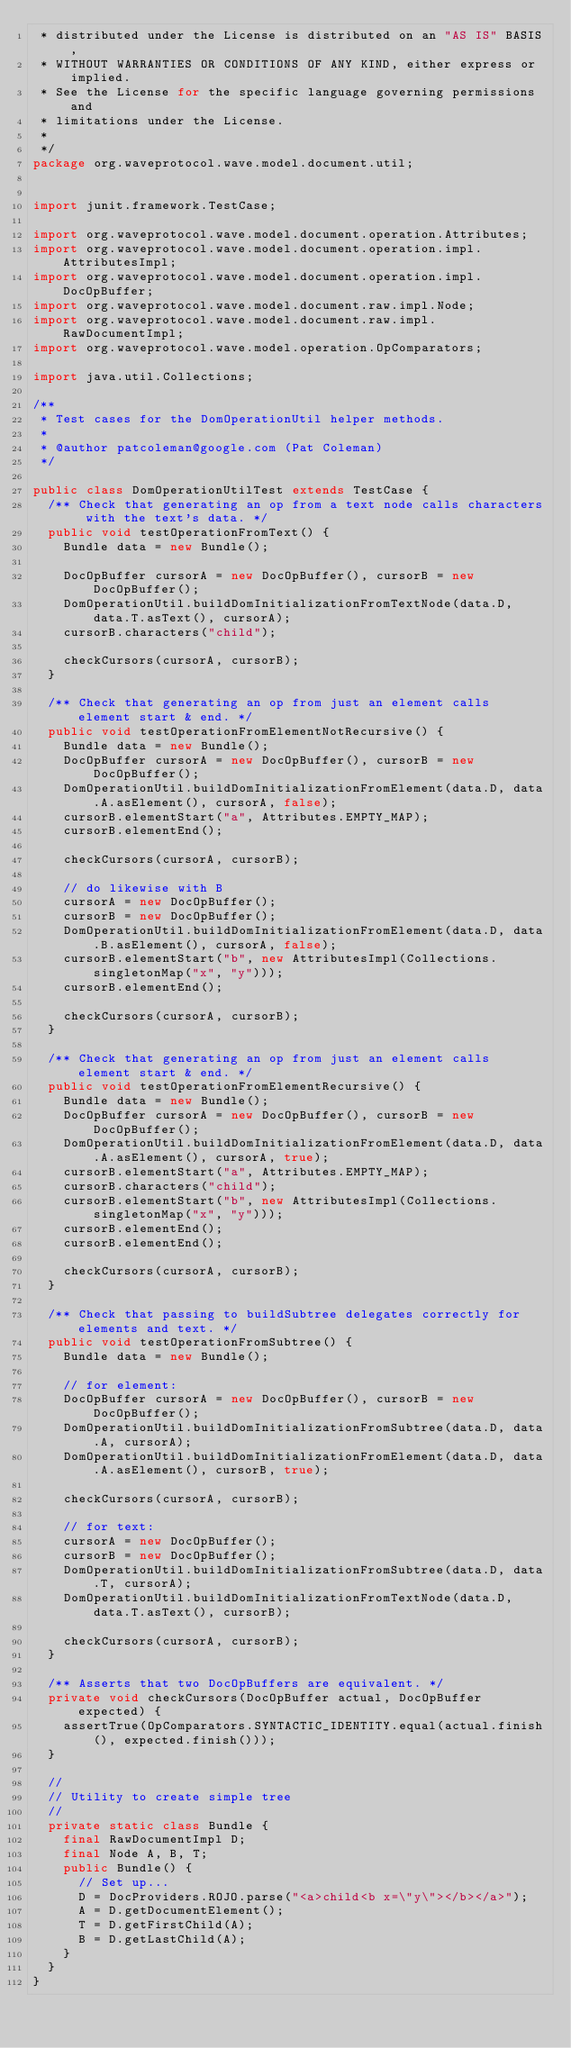Convert code to text. <code><loc_0><loc_0><loc_500><loc_500><_Java_> * distributed under the License is distributed on an "AS IS" BASIS,
 * WITHOUT WARRANTIES OR CONDITIONS OF ANY KIND, either express or implied.
 * See the License for the specific language governing permissions and
 * limitations under the License.
 *
 */
package org.waveprotocol.wave.model.document.util;


import junit.framework.TestCase;

import org.waveprotocol.wave.model.document.operation.Attributes;
import org.waveprotocol.wave.model.document.operation.impl.AttributesImpl;
import org.waveprotocol.wave.model.document.operation.impl.DocOpBuffer;
import org.waveprotocol.wave.model.document.raw.impl.Node;
import org.waveprotocol.wave.model.document.raw.impl.RawDocumentImpl;
import org.waveprotocol.wave.model.operation.OpComparators;

import java.util.Collections;

/**
 * Test cases for the DomOperationUtil helper methods.
 *
 * @author patcoleman@google.com (Pat Coleman)
 */

public class DomOperationUtilTest extends TestCase {
  /** Check that generating an op from a text node calls characters with the text's data. */
  public void testOperationFromText() {
    Bundle data = new Bundle();

    DocOpBuffer cursorA = new DocOpBuffer(), cursorB = new DocOpBuffer();
    DomOperationUtil.buildDomInitializationFromTextNode(data.D, data.T.asText(), cursorA);
    cursorB.characters("child");

    checkCursors(cursorA, cursorB);
  }

  /** Check that generating an op from just an element calls element start & end. */
  public void testOperationFromElementNotRecursive() {
    Bundle data = new Bundle();
    DocOpBuffer cursorA = new DocOpBuffer(), cursorB = new DocOpBuffer();
    DomOperationUtil.buildDomInitializationFromElement(data.D, data.A.asElement(), cursorA, false);
    cursorB.elementStart("a", Attributes.EMPTY_MAP);
    cursorB.elementEnd();

    checkCursors(cursorA, cursorB);

    // do likewise with B
    cursorA = new DocOpBuffer();
    cursorB = new DocOpBuffer();
    DomOperationUtil.buildDomInitializationFromElement(data.D, data.B.asElement(), cursorA, false);
    cursorB.elementStart("b", new AttributesImpl(Collections.singletonMap("x", "y")));
    cursorB.elementEnd();

    checkCursors(cursorA, cursorB);
  }

  /** Check that generating an op from just an element calls element start & end. */
  public void testOperationFromElementRecursive() {
    Bundle data = new Bundle();
    DocOpBuffer cursorA = new DocOpBuffer(), cursorB = new DocOpBuffer();
    DomOperationUtil.buildDomInitializationFromElement(data.D, data.A.asElement(), cursorA, true);
    cursorB.elementStart("a", Attributes.EMPTY_MAP);
    cursorB.characters("child");
    cursorB.elementStart("b", new AttributesImpl(Collections.singletonMap("x", "y")));
    cursorB.elementEnd();
    cursorB.elementEnd();

    checkCursors(cursorA, cursorB);
  }

  /** Check that passing to buildSubtree delegates correctly for elements and text. */
  public void testOperationFromSubtree() {
    Bundle data = new Bundle();

    // for element:
    DocOpBuffer cursorA = new DocOpBuffer(), cursorB = new DocOpBuffer();
    DomOperationUtil.buildDomInitializationFromSubtree(data.D, data.A, cursorA);
    DomOperationUtil.buildDomInitializationFromElement(data.D, data.A.asElement(), cursorB, true);

    checkCursors(cursorA, cursorB);

    // for text:
    cursorA = new DocOpBuffer();
    cursorB = new DocOpBuffer();
    DomOperationUtil.buildDomInitializationFromSubtree(data.D, data.T, cursorA);
    DomOperationUtil.buildDomInitializationFromTextNode(data.D, data.T.asText(), cursorB);

    checkCursors(cursorA, cursorB);
  }

  /** Asserts that two DocOpBuffers are equivalent. */
  private void checkCursors(DocOpBuffer actual, DocOpBuffer expected) {
    assertTrue(OpComparators.SYNTACTIC_IDENTITY.equal(actual.finish(), expected.finish()));
  }

  //
  // Utility to create simple tree
  //
  private static class Bundle {
    final RawDocumentImpl D;
    final Node A, B, T;
    public Bundle() {
      // Set up...
      D = DocProviders.ROJO.parse("<a>child<b x=\"y\"></b></a>");
      A = D.getDocumentElement();
      T = D.getFirstChild(A);
      B = D.getLastChild(A);
    }
  }
}
</code> 